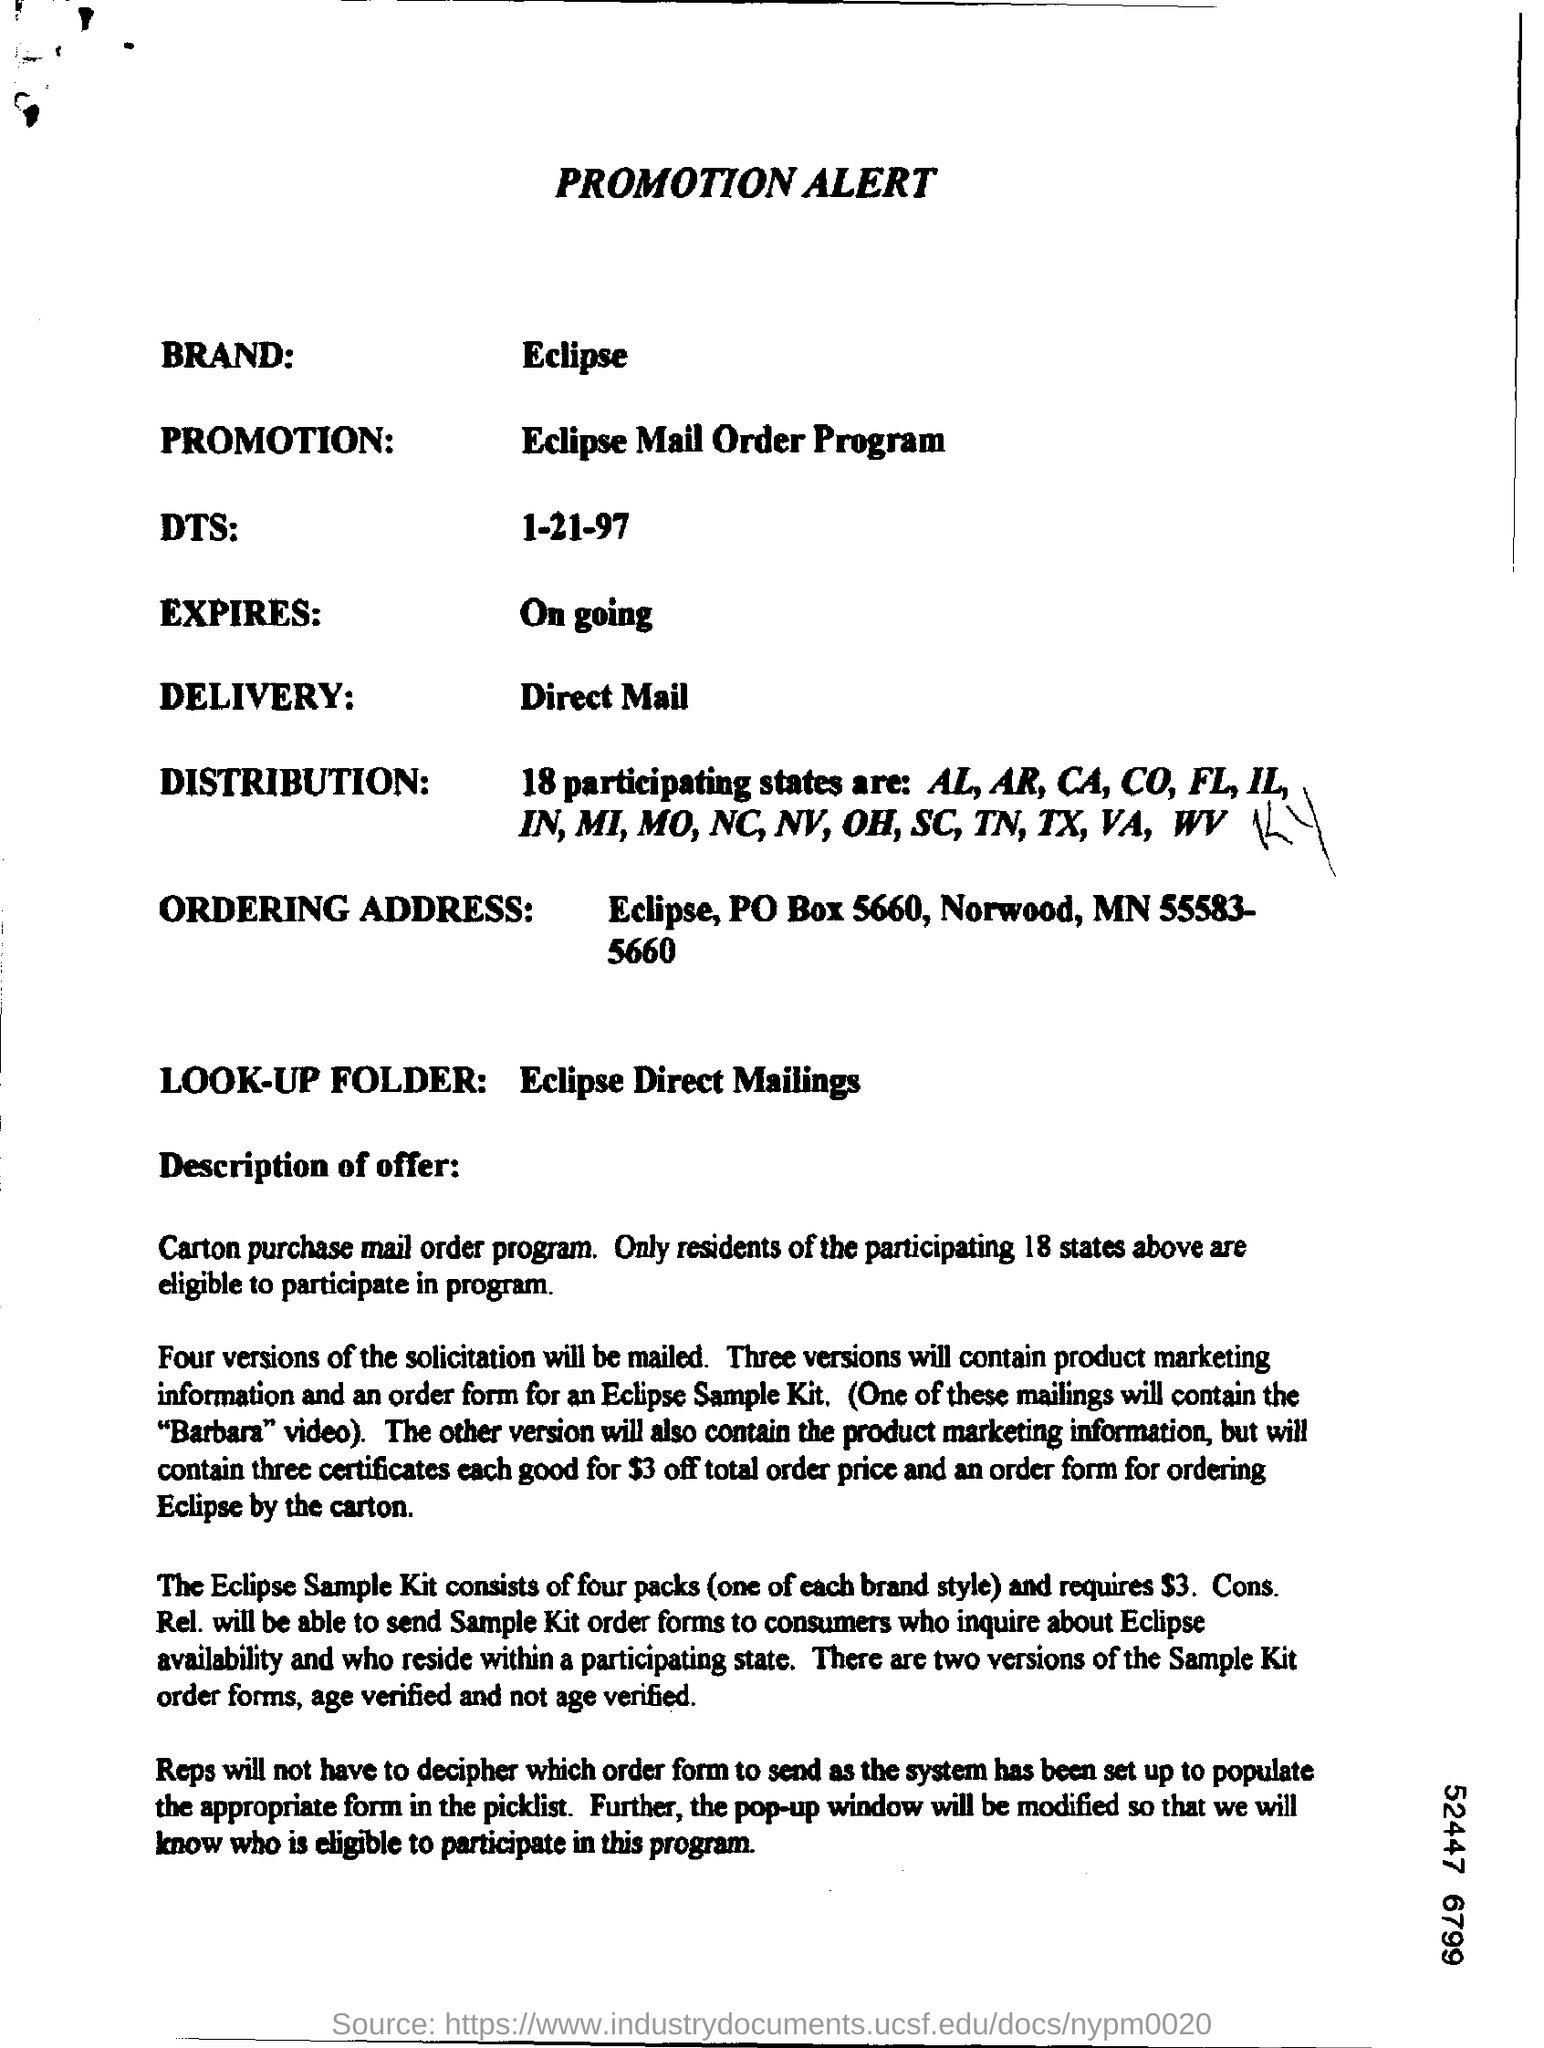Mention a couple of crucial points in this snapshot. As part of the Eclipse Mail Order Program, the promotion involves the sale of Eclipse products through a mail order format. The brand is Eclipse. What is the DTS? 1-21-97 is a date. 